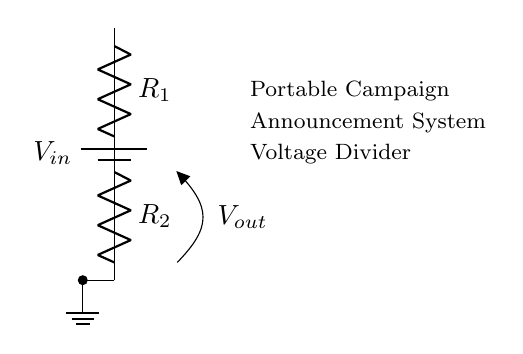what does V in the battery represent? The V in the battery represents the input voltage of the circuit, denoting the potential difference that drives the current through the voltage divider. In this circuit, it is labeled as \( V_{in} \).
Answer: input voltage what are the two components of the voltage divider? The two components of the voltage divider are two resistors, labeled as \( R_1 \) and \( R_2 \). They are arranged in series with the battery.
Answer: R1 and R2 what is the output voltage represented as? The output voltage is represented as \( V_{out} \), which is taken from the junction between the two resistors. This voltage is dependent on the resistor values and the input voltage.
Answer: Vout how are the resistors connected in the circuit? The resistors are connected in series, meaning the current flows through \( R_1 \) before reaching \( R_2 \). This series configuration affects the voltage distribution across each resistor.
Answer: in series what affects the output voltage in a voltage divider? The output voltage in a voltage divider is affected by the values of the resistors \( R_1 \) and \( R_2 \) and the input voltage \( V_{in} \). The output voltage can be calculated by the formula: \( V_{out} = V_{in} \times \frac{R_2}{R_1 + R_2} \).
Answer: resistor values and input voltage where is the ground connection located? The ground connection is located at the bottom of the circuit diagram, which is indicated by the ground symbol. It serves as the reference point for measuring voltages in the circuit.
Answer: bottom 